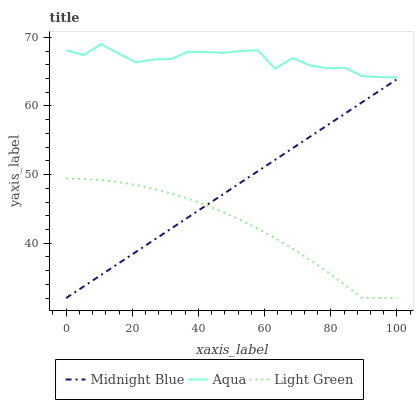Does Light Green have the minimum area under the curve?
Answer yes or no. Yes. Does Aqua have the maximum area under the curve?
Answer yes or no. Yes. Does Midnight Blue have the minimum area under the curve?
Answer yes or no. No. Does Midnight Blue have the maximum area under the curve?
Answer yes or no. No. Is Midnight Blue the smoothest?
Answer yes or no. Yes. Is Aqua the roughest?
Answer yes or no. Yes. Is Light Green the smoothest?
Answer yes or no. No. Is Light Green the roughest?
Answer yes or no. No. Does Midnight Blue have the lowest value?
Answer yes or no. Yes. Does Aqua have the highest value?
Answer yes or no. Yes. Does Midnight Blue have the highest value?
Answer yes or no. No. Is Light Green less than Aqua?
Answer yes or no. Yes. Is Aqua greater than Midnight Blue?
Answer yes or no. Yes. Does Midnight Blue intersect Light Green?
Answer yes or no. Yes. Is Midnight Blue less than Light Green?
Answer yes or no. No. Is Midnight Blue greater than Light Green?
Answer yes or no. No. Does Light Green intersect Aqua?
Answer yes or no. No. 